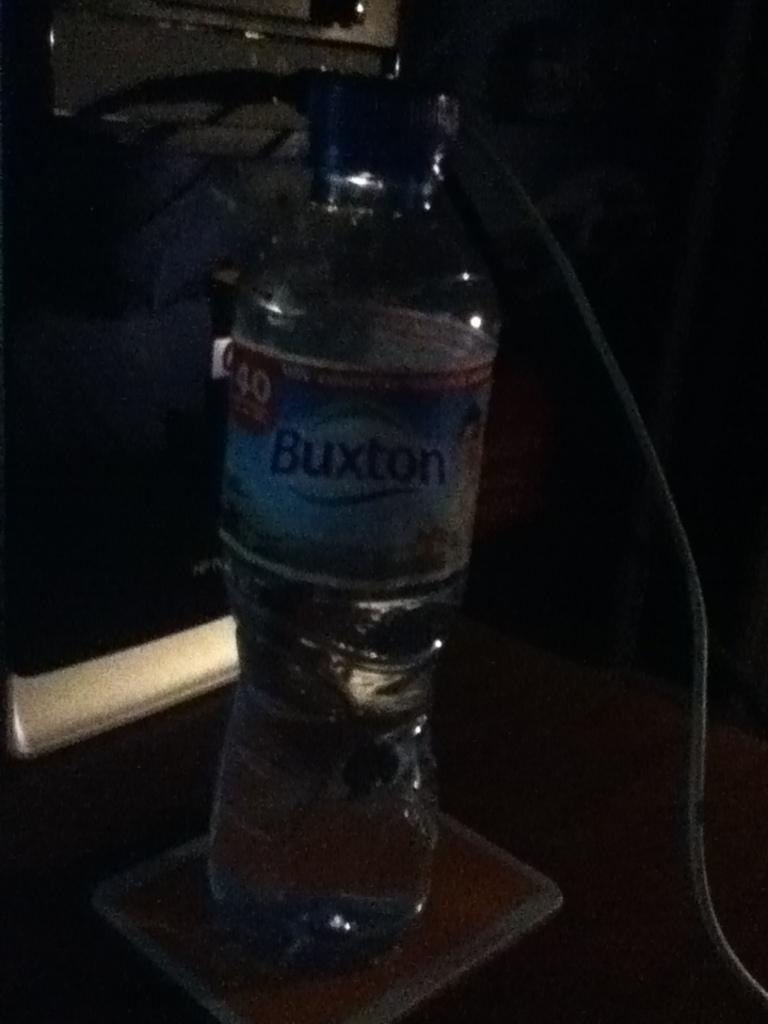<image>
Give a short and clear explanation of the subsequent image. a bottle with the word Buxton on it 